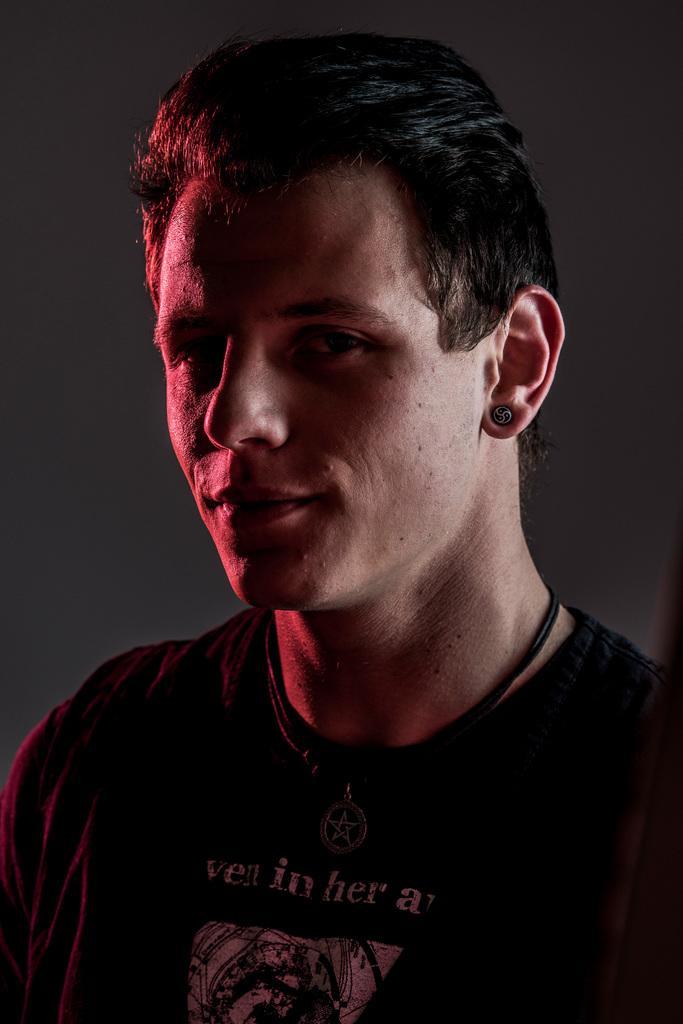In one or two sentences, can you explain what this image depicts? In this image, we can see a man wearing a black color shirt. In the background, we can see black color. 